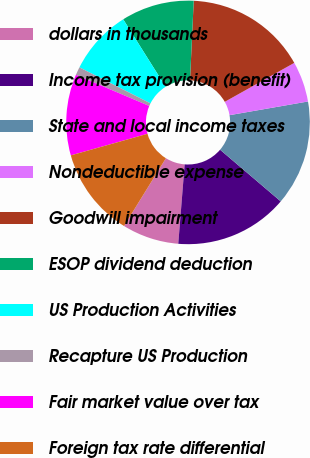<chart> <loc_0><loc_0><loc_500><loc_500><pie_chart><fcel>dollars in thousands<fcel>Income tax provision (benefit)<fcel>State and local income taxes<fcel>Nondeductible expense<fcel>Goodwill impairment<fcel>ESOP dividend deduction<fcel>US Production Activities<fcel>Recapture US Production<fcel>Fair market value over tax<fcel>Foreign tax rate differential<nl><fcel>7.53%<fcel>15.05%<fcel>13.98%<fcel>5.38%<fcel>16.13%<fcel>9.68%<fcel>8.6%<fcel>1.08%<fcel>10.75%<fcel>11.83%<nl></chart> 